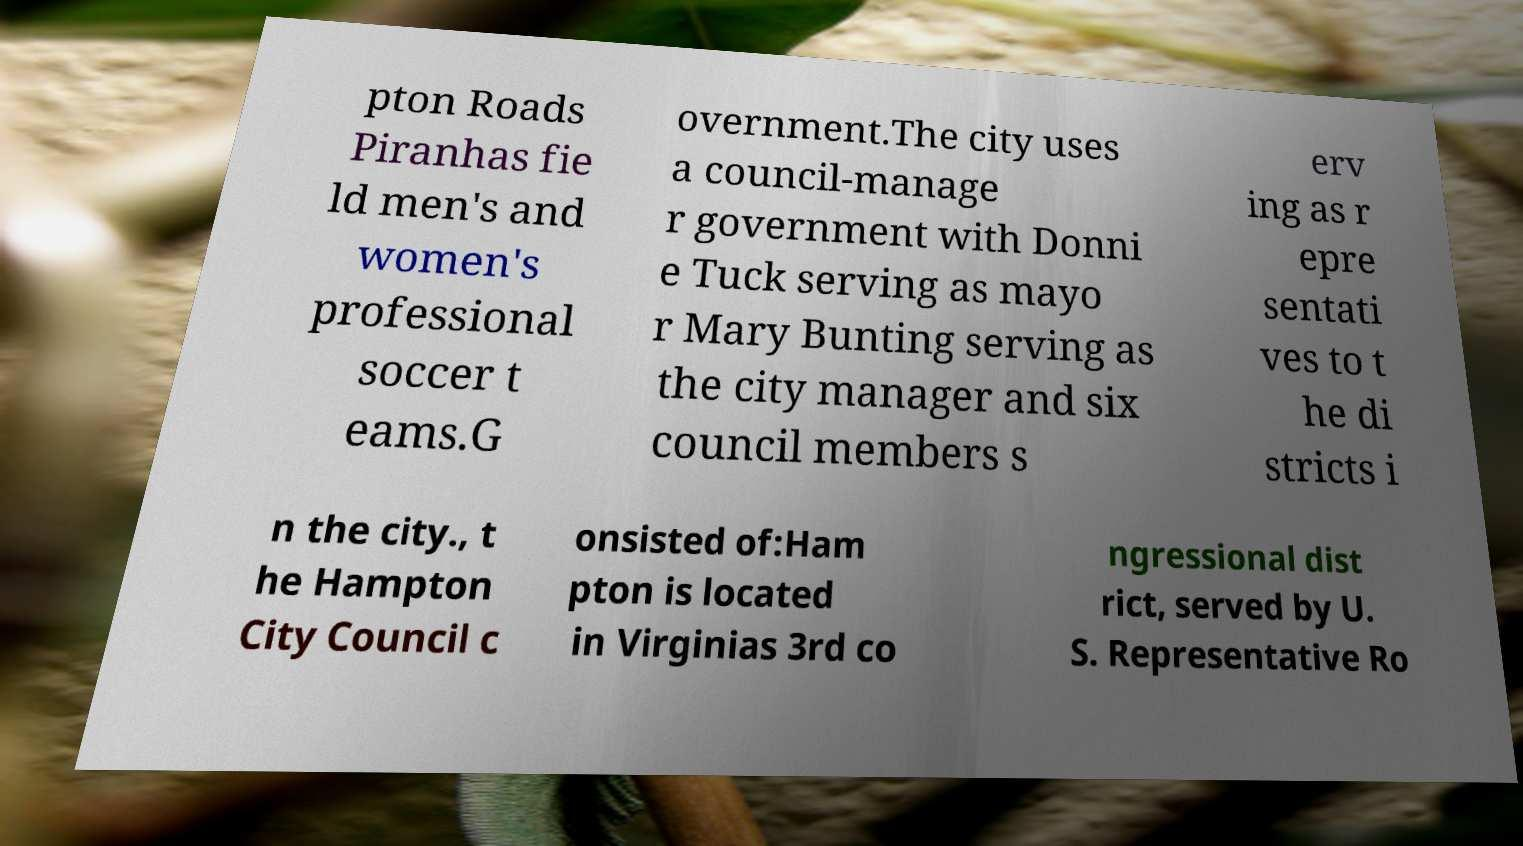Can you read and provide the text displayed in the image?This photo seems to have some interesting text. Can you extract and type it out for me? pton Roads Piranhas fie ld men's and women's professional soccer t eams.G overnment.The city uses a council-manage r government with Donni e Tuck serving as mayo r Mary Bunting serving as the city manager and six council members s erv ing as r epre sentati ves to t he di stricts i n the city., t he Hampton City Council c onsisted of:Ham pton is located in Virginias 3rd co ngressional dist rict, served by U. S. Representative Ro 